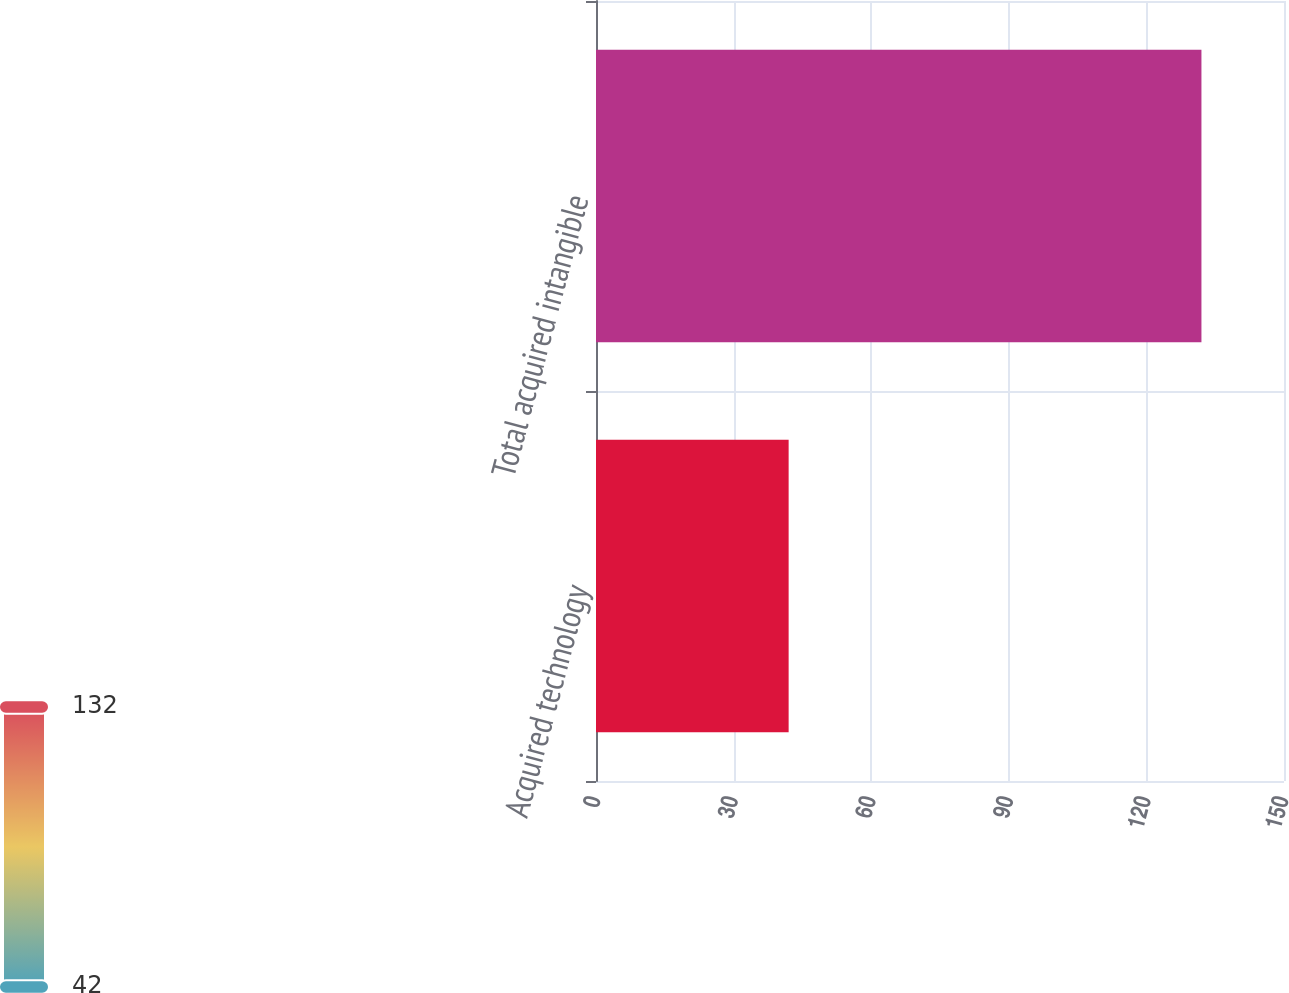<chart> <loc_0><loc_0><loc_500><loc_500><bar_chart><fcel>Acquired technology<fcel>Total acquired intangible<nl><fcel>42<fcel>132<nl></chart> 